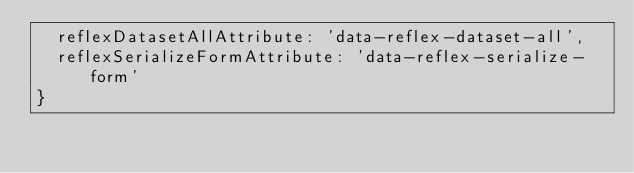<code> <loc_0><loc_0><loc_500><loc_500><_JavaScript_>  reflexDatasetAllAttribute: 'data-reflex-dataset-all',
  reflexSerializeFormAttribute: 'data-reflex-serialize-form'
}
</code> 